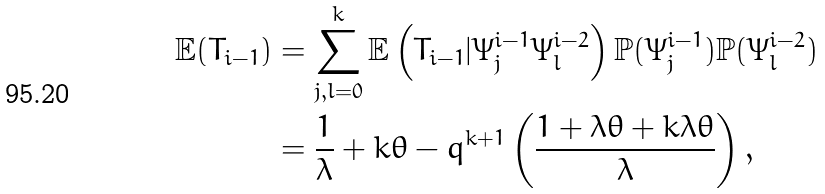Convert formula to latex. <formula><loc_0><loc_0><loc_500><loc_500>\mathbb { E } ( T _ { i - 1 } ) & = \sum _ { j , l = 0 } ^ { k } \mathbb { E } \left ( T _ { i - 1 } | \Psi _ { j } ^ { i - 1 } \Psi _ { l } ^ { i - 2 } \right ) \mathbb { P } ( \Psi _ { j } ^ { i - 1 } ) \mathbb { P } ( \Psi _ { l } ^ { i - 2 } ) \\ & = \frac { 1 } { \lambda } + k \theta - q ^ { k + 1 } \left ( \frac { 1 + \lambda \theta + k \lambda \theta } { \lambda } \right ) ,</formula> 